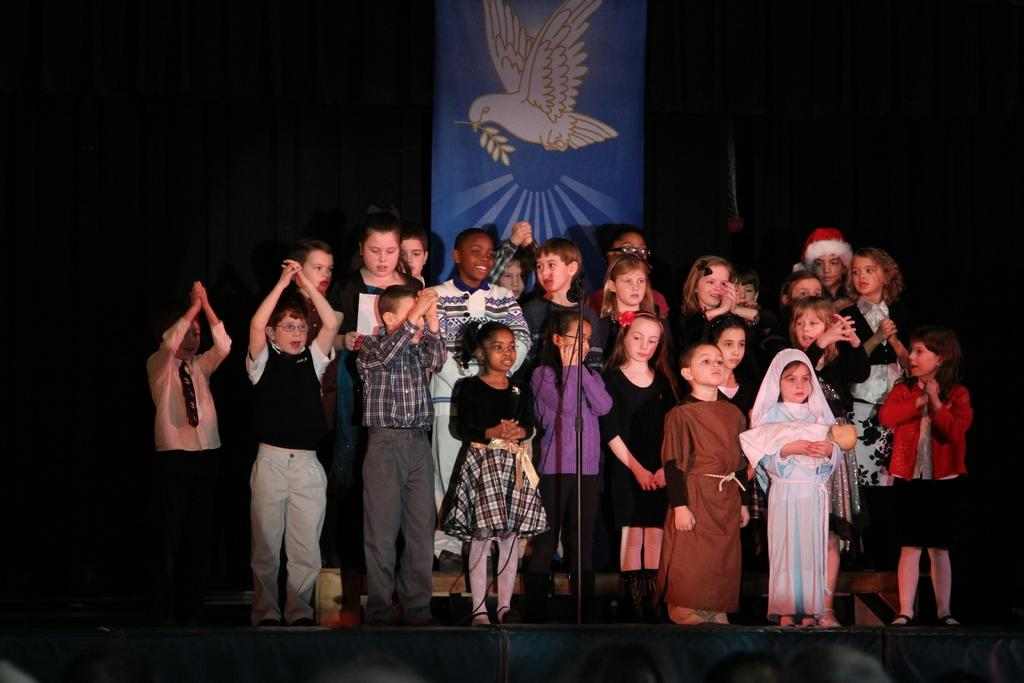Who is present in the image? There are children in the image. What are the children wearing? The children are dressed in costumes. Where are the children standing? The children are standing on a dais. What object is placed in front of the children? A microphone is placed in front of the children. What can be seen in the background of the image? There is a curtain in the background of the image. What type of plants can be seen growing in the image? There are no plants visible in the image. How many cans of soda are present in the image? There is no mention of cans or soda in the image. 